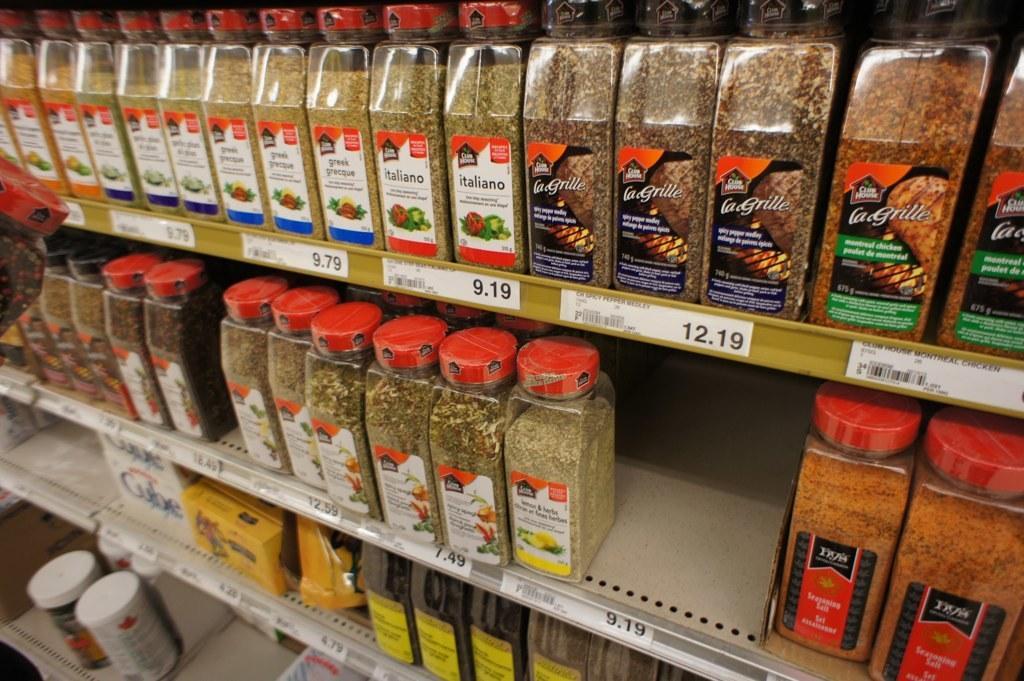Please provide a concise description of this image. In this image we can see jars, items in the bottles are on the racks and we can see price tags. 